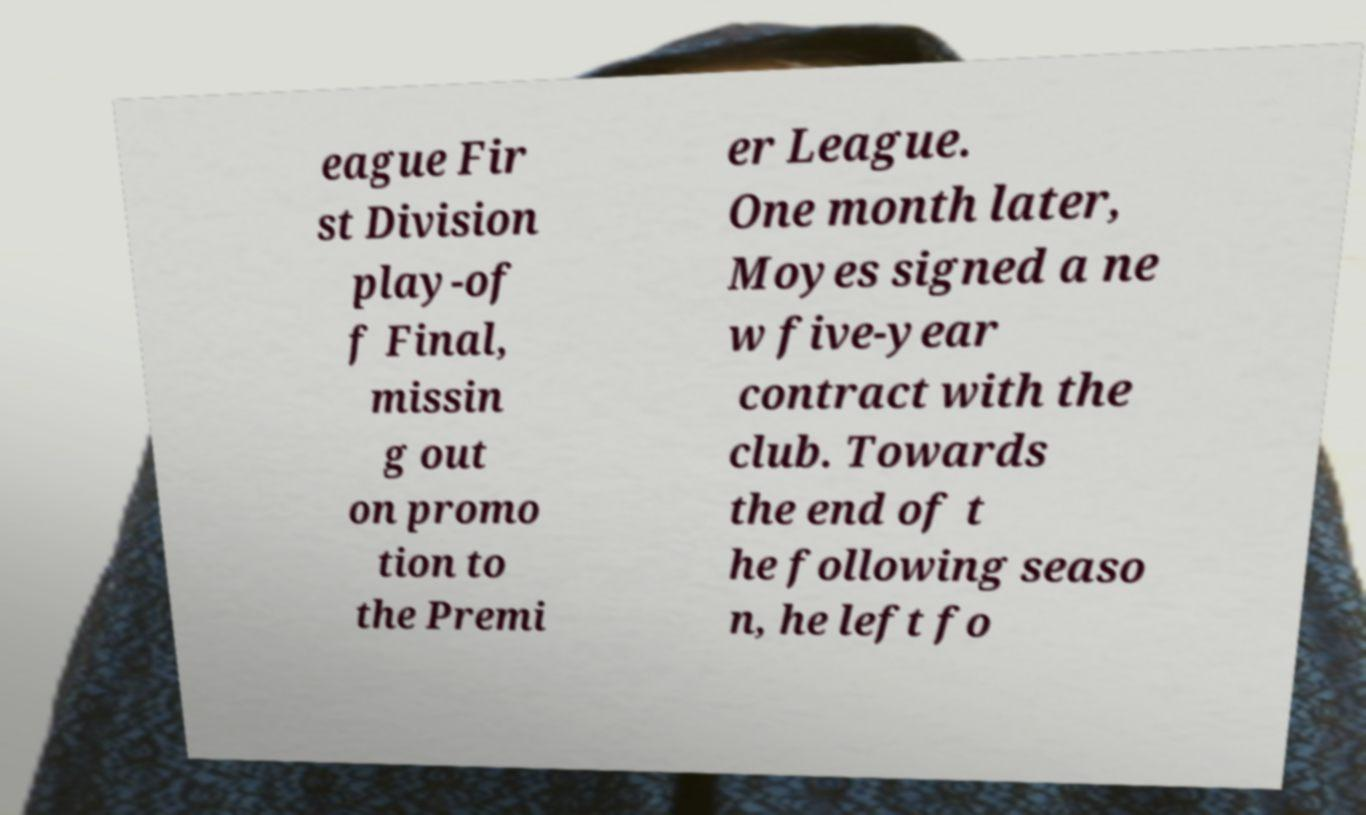Could you assist in decoding the text presented in this image and type it out clearly? eague Fir st Division play-of f Final, missin g out on promo tion to the Premi er League. One month later, Moyes signed a ne w five-year contract with the club. Towards the end of t he following seaso n, he left fo 